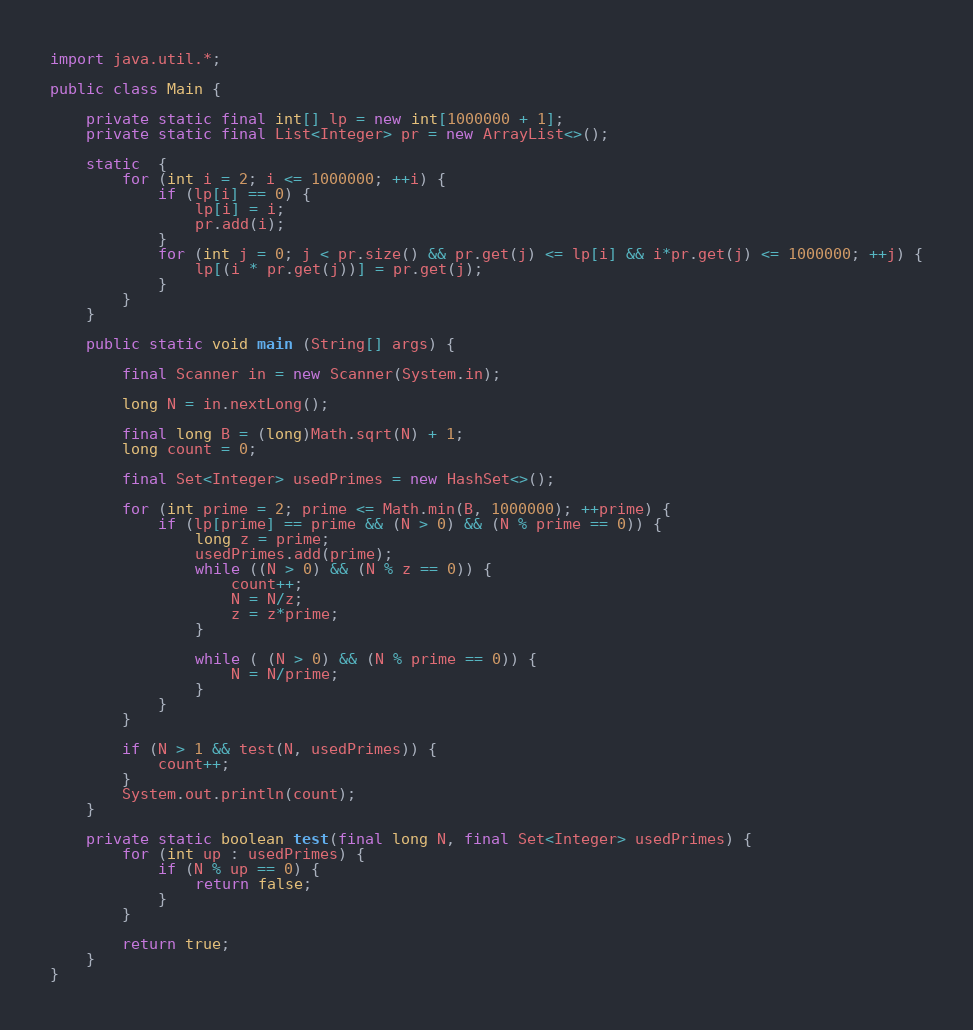Convert code to text. <code><loc_0><loc_0><loc_500><loc_500><_Java_>import java.util.*;

public class Main {

    private static final int[] lp = new int[1000000 + 1];
    private static final List<Integer> pr = new ArrayList<>();

    static  {
        for (int i = 2; i <= 1000000; ++i) {
            if (lp[i] == 0) {
                lp[i] = i;
                pr.add(i);
            }
            for (int j = 0; j < pr.size() && pr.get(j) <= lp[i] && i*pr.get(j) <= 1000000; ++j) {
                lp[(i * pr.get(j))] = pr.get(j);
            }
        }
    }

    public static void main (String[] args) {

        final Scanner in = new Scanner(System.in);

        long N = in.nextLong();

        final long B = (long)Math.sqrt(N) + 1;
        long count = 0;

        final Set<Integer> usedPrimes = new HashSet<>();

        for (int prime = 2; prime <= Math.min(B, 1000000); ++prime) {
            if (lp[prime] == prime && (N > 0) && (N % prime == 0)) {
                long z = prime;
                usedPrimes.add(prime);
                while ((N > 0) && (N % z == 0)) {
                    count++;
                    N = N/z;
                    z = z*prime;
                }

                while ( (N > 0) && (N % prime == 0)) {
                    N = N/prime;
                }
            }
        }

        if (N > 1 && test(N, usedPrimes)) {
            count++;
        }
        System.out.println(count);
    }

    private static boolean test(final long N, final Set<Integer> usedPrimes) {
        for (int up : usedPrimes) {
            if (N % up == 0) {
                return false;
            }
        }

        return true;
    }
}</code> 